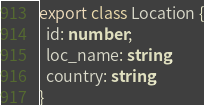Convert code to text. <code><loc_0><loc_0><loc_500><loc_500><_TypeScript_>export class Location {
  id: number;
  loc_name: string;
  country: string;
}
</code> 